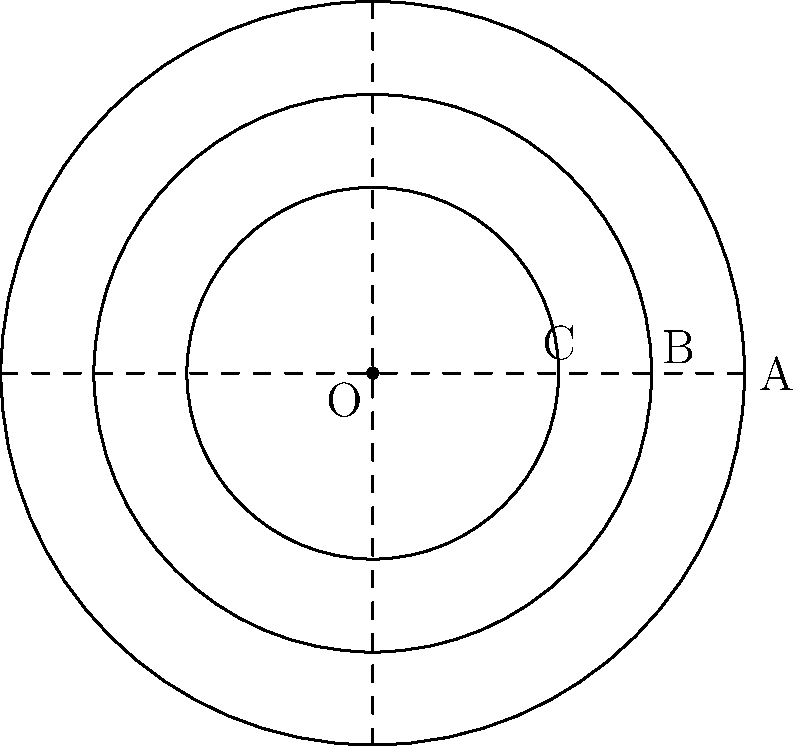In this abstract representation of tree rings, three concentric circles are centered at point O. If the radius of the largest circle is 2 units and the radius of the smallest circle is 1 unit, what is the area of the shaded region between the middle and smallest circles? Let's approach this step-by-step:

1) We're given that the radius of the largest circle (OA) is 2 units and the radius of the smallest circle (OC) is 1 unit.

2) Let's denote the radius of the middle circle (OB) as $r$.

3) The area of the shaded region will be the difference between the area of the middle circle and the area of the smallest circle.

4) Area of a circle is given by the formula $A = \pi r^2$.

5) Area of the middle circle: $A_2 = \pi r^2$
   Area of the smallest circle: $A_3 = \pi (1)^2 = \pi$

6) The shaded area is: $A_{shaded} = A_2 - A_3 = \pi r^2 - \pi$

7) To find $r$, we can use the property of symmetry in the tree ring pattern. In nature, tree rings often form at regular intervals. If we assume this pattern, then:

   $\frac{OB - OC}{OA - OB} = 1$

   $\frac{r - 1}{2 - r} = 1$

8) Solving this equation:
   $r - 1 = 2 - r$
   $2r = 3$
   $r = 1.5$

9) Now we can calculate the shaded area:
   $A_{shaded} = \pi (1.5)^2 - \pi = 2.25\pi - \pi = 1.25\pi$

Therefore, the area of the shaded region is $1.25\pi$ square units.
Answer: $1.25\pi$ square units 